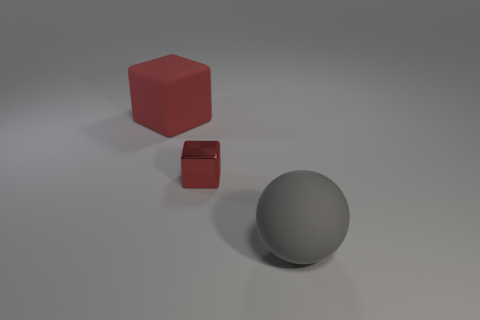Add 3 big brown matte objects. How many objects exist? 6 Subtract all blocks. How many objects are left? 1 Subtract all purple cubes. Subtract all brown cylinders. How many cubes are left? 2 Add 1 gray matte things. How many gray matte things are left? 2 Add 2 gray matte spheres. How many gray matte spheres exist? 3 Subtract 2 red cubes. How many objects are left? 1 Subtract 2 cubes. How many cubes are left? 0 Subtract all purple cylinders. How many green blocks are left? 0 Subtract all objects. Subtract all cyan matte cylinders. How many objects are left? 0 